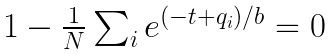Convert formula to latex. <formula><loc_0><loc_0><loc_500><loc_500>\begin{array} { l } 1 - \frac { 1 } { N } \sum _ { i } e ^ { ( - t + q _ { i } ) / b } = 0 \end{array}</formula> 